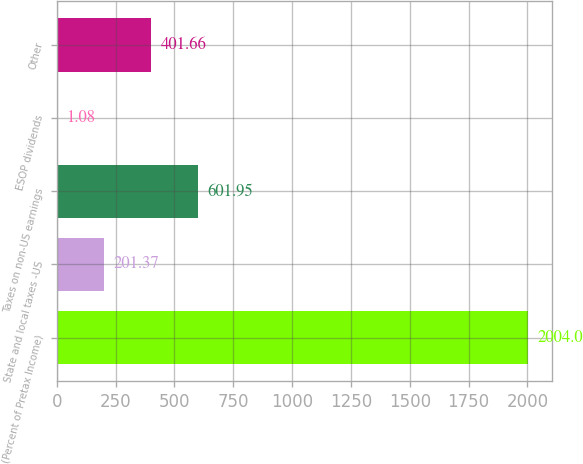Convert chart. <chart><loc_0><loc_0><loc_500><loc_500><bar_chart><fcel>(Percent of Pretax Income)<fcel>State and local taxes -US<fcel>Taxes on non-US earnings<fcel>ESOP dividends<fcel>Other<nl><fcel>2004<fcel>201.37<fcel>601.95<fcel>1.08<fcel>401.66<nl></chart> 